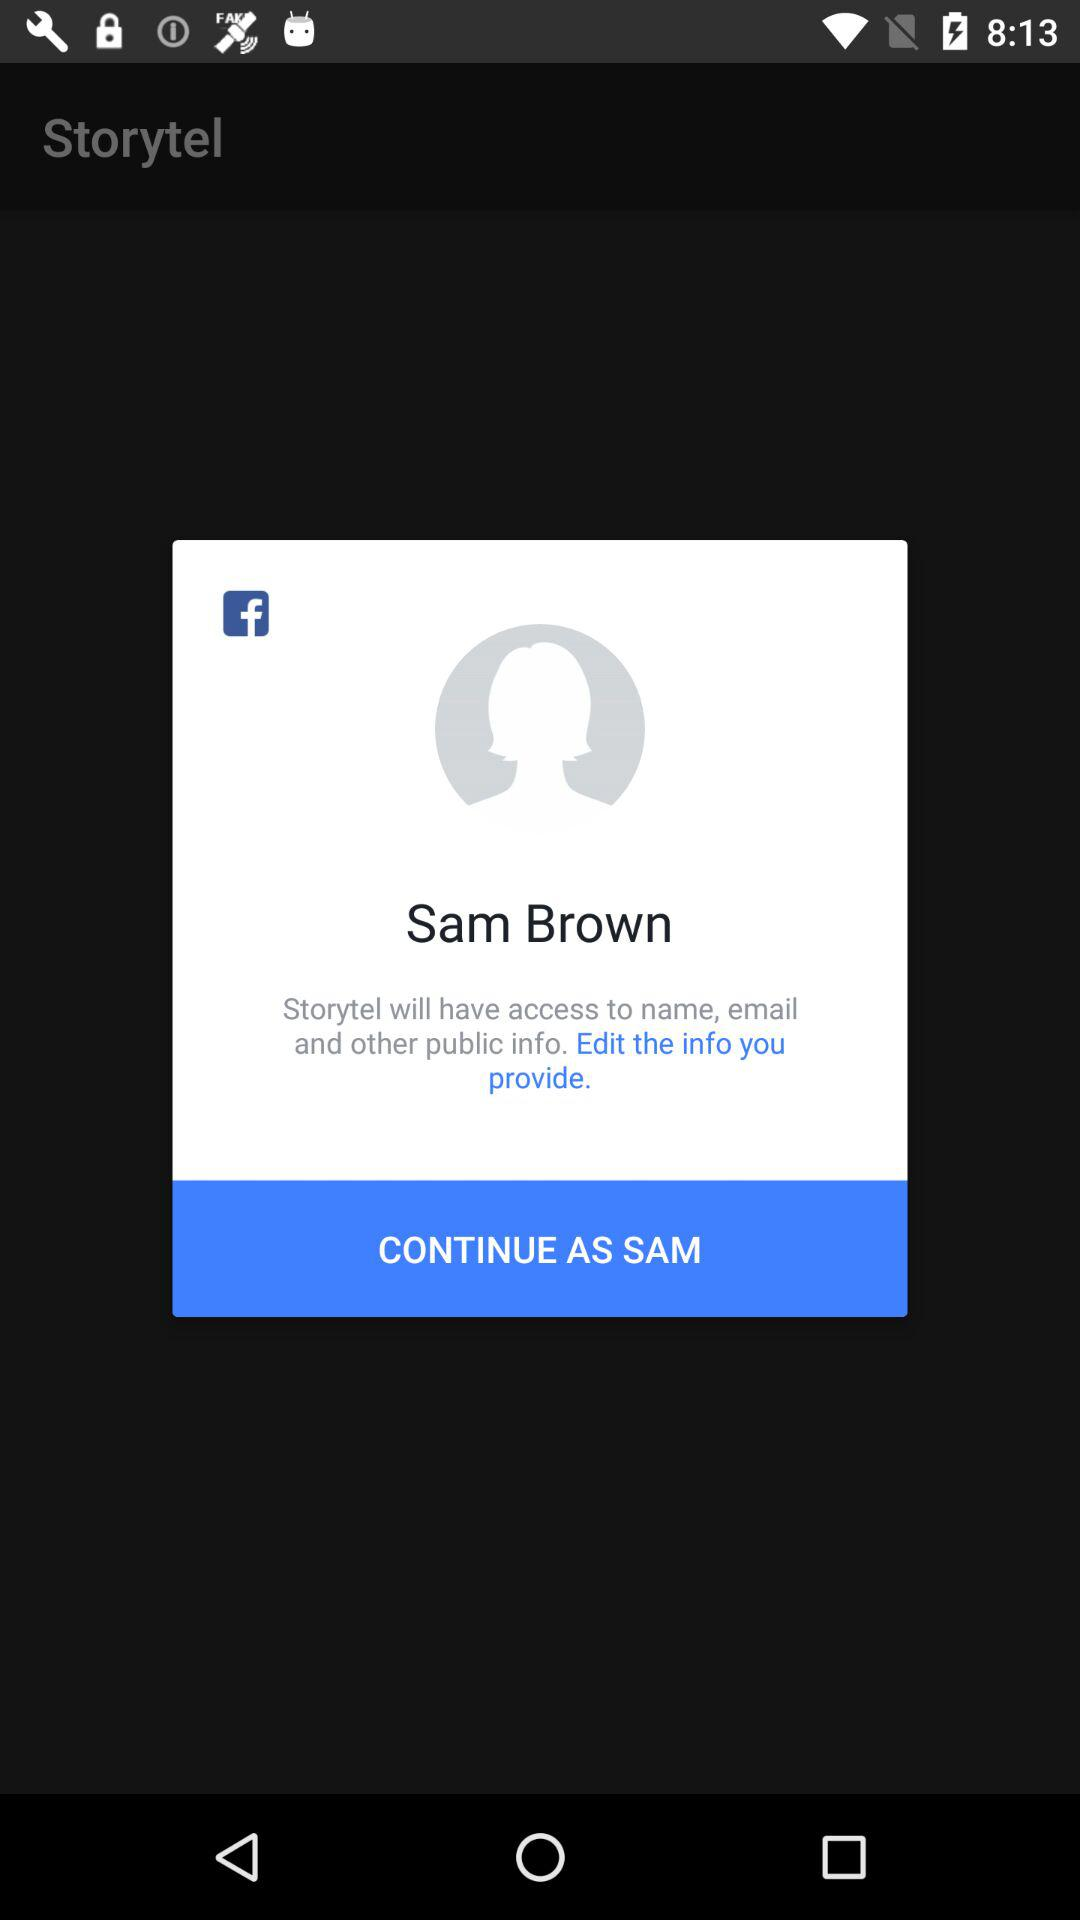What is the login name? The login name is Sam Brown. 